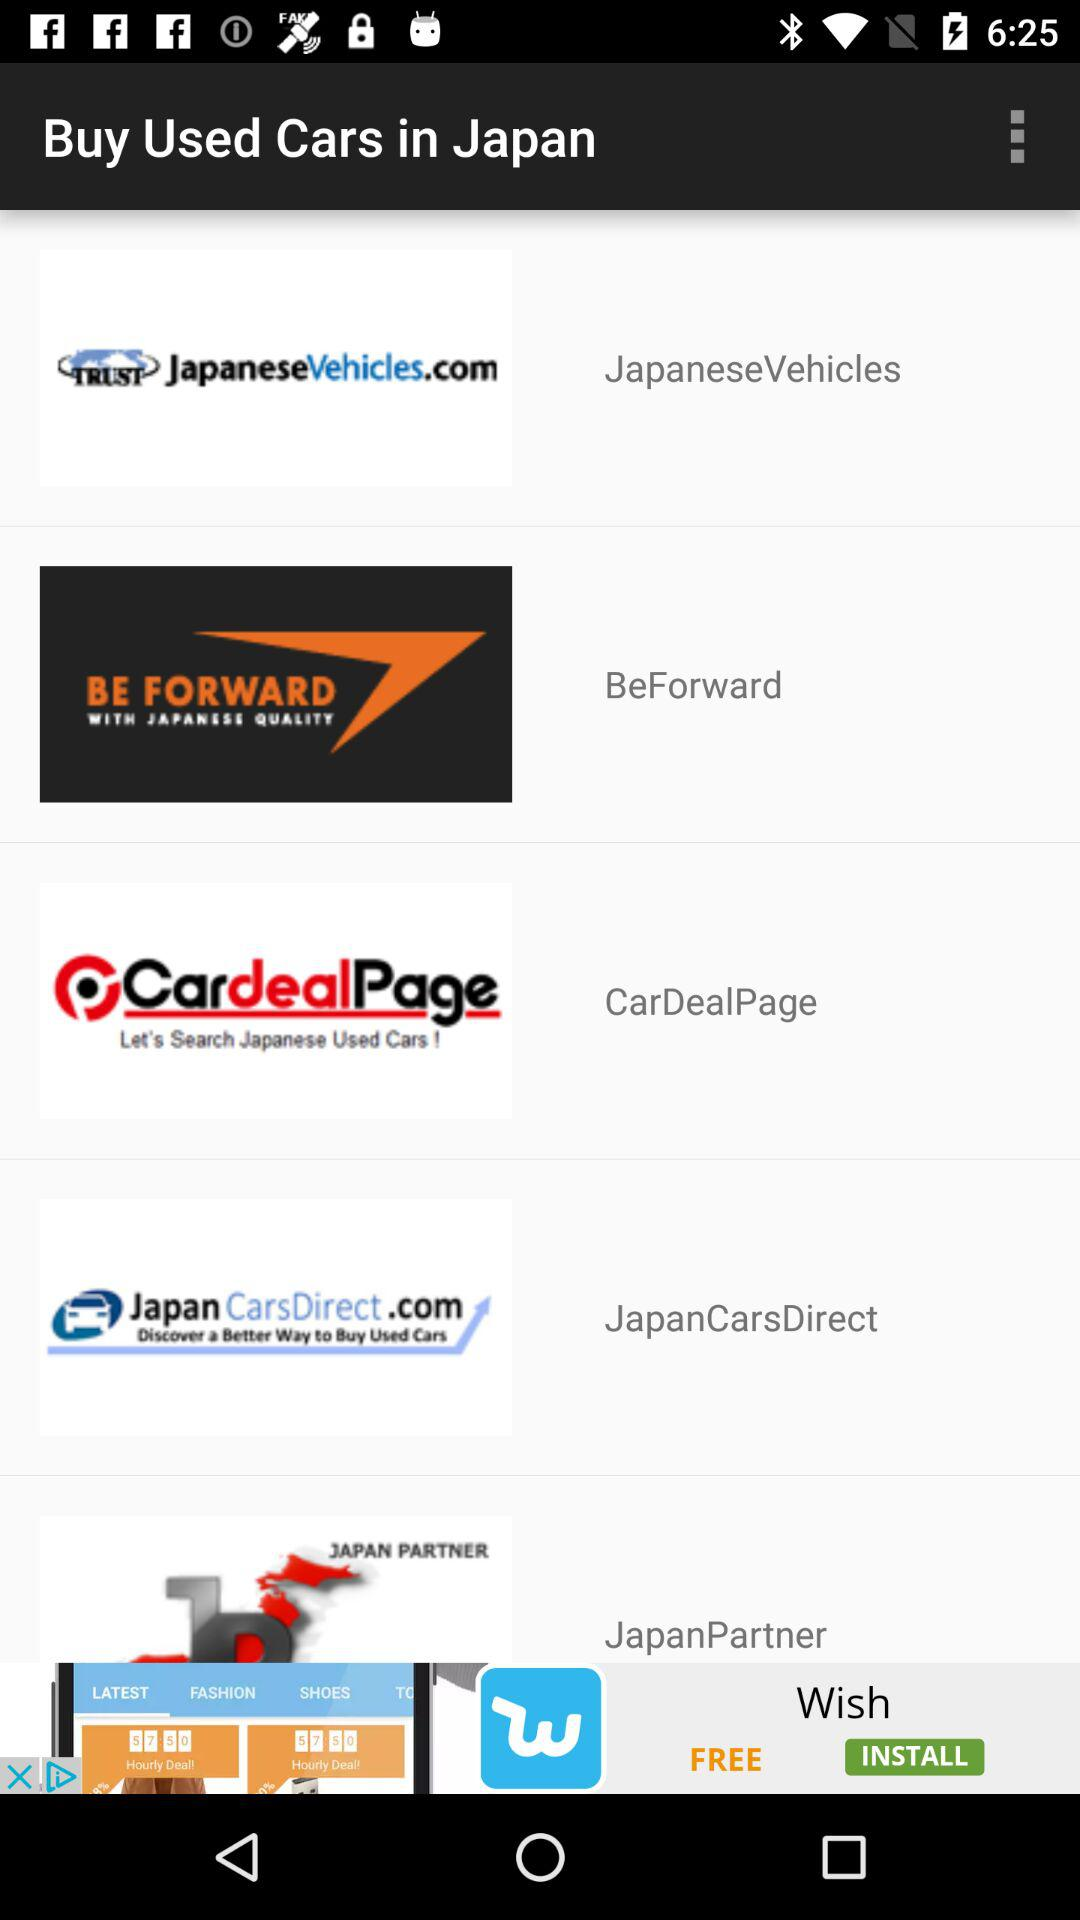What is the mentioned location? The mentioned location is Japan. 